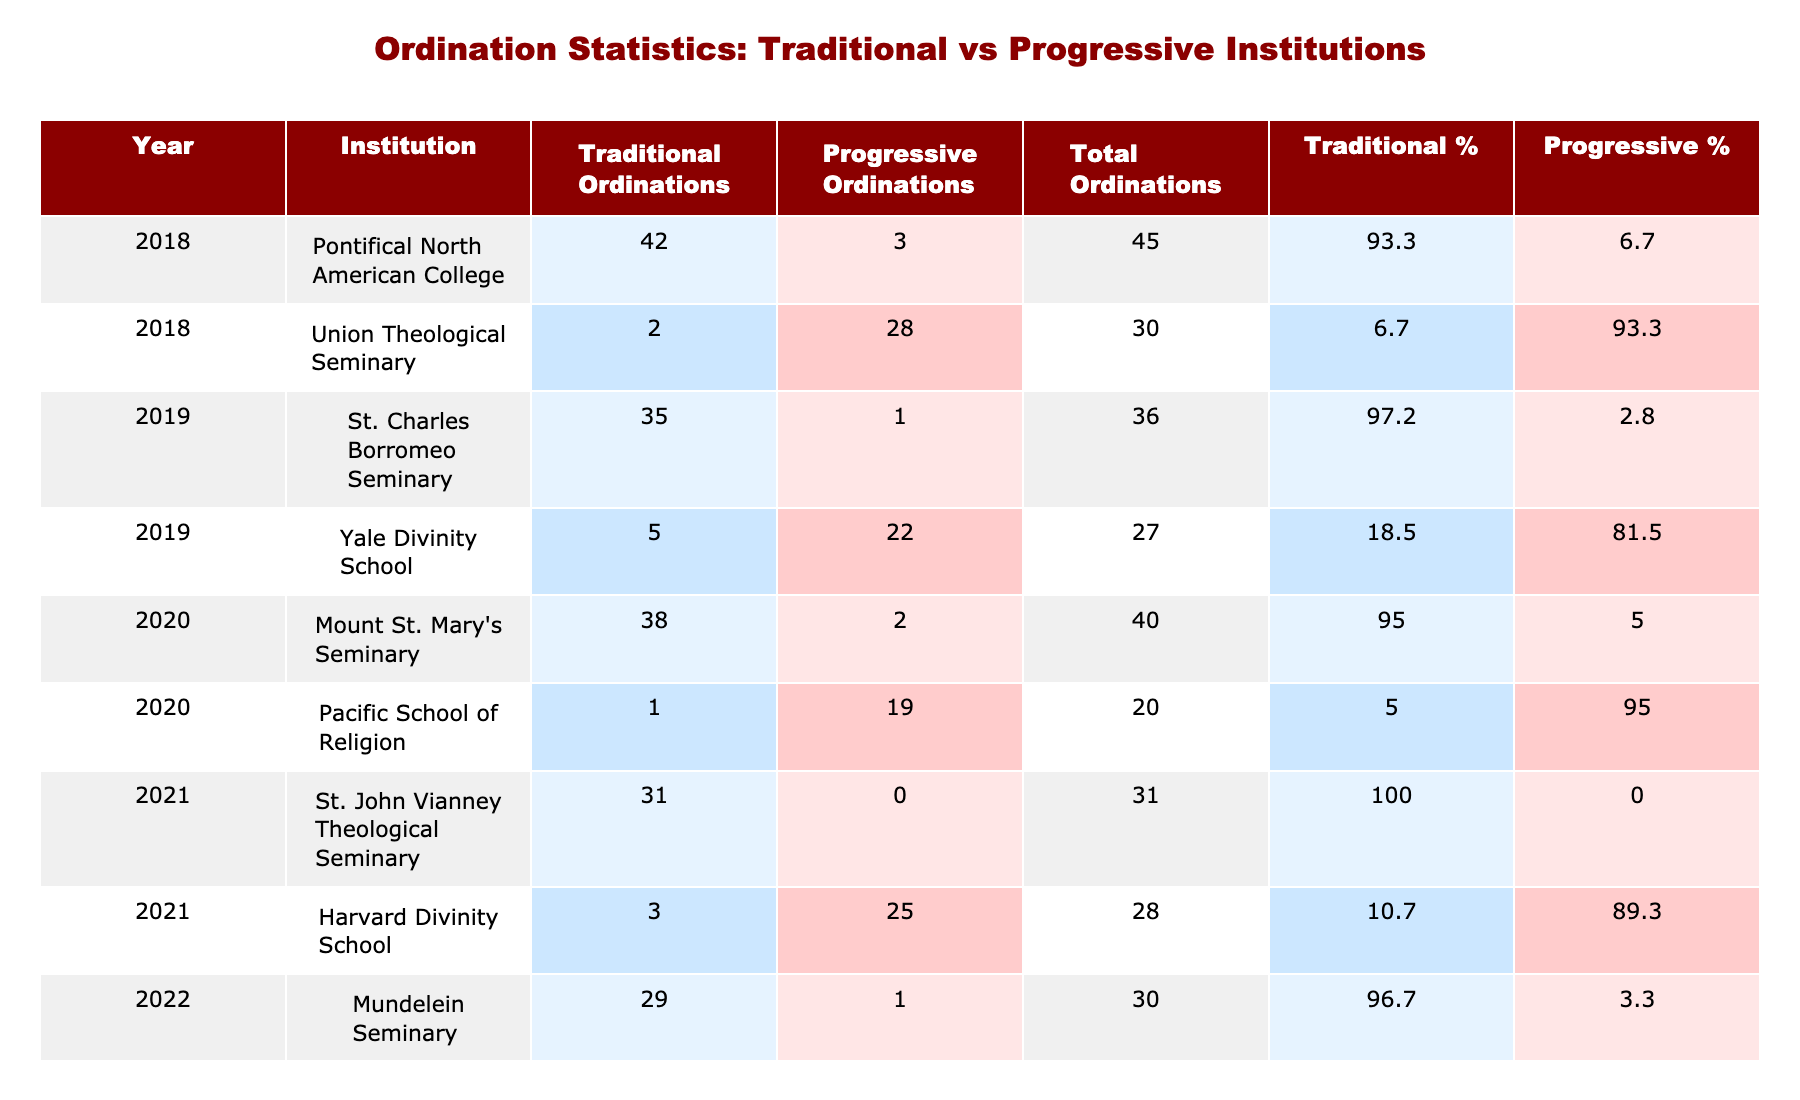What institution had the highest number of traditional ordinations in 2018? In 2018, the Pontifical North American College had 42 traditional ordinations, which is the highest compared to other institutions in that year.
Answer: Pontifical North American College What is the total number of progressive ordinations in 2020? In 2020, there were 2 progressive ordinations at Mount St. Mary's Seminary and 19 at Pacific School of Religion. The total is 2 + 19 = 21.
Answer: 21 Which institution had more traditional ordinations than progressive ordinations in 2019? In 2019, St. Charles Borromeo Seminary had 35 traditional ordinations and only 1 progressive ordination, indicating it had more traditional ordinations than progressive ones.
Answer: St. Charles Borromeo Seminary What percentage of total ordinations were traditional at Harvard Divinity School in 2021? Harvard Divinity School had 3 traditional ordinations and 25 progressive ordinations in 2021. The total ordinations were 3 + 25 = 28. The percentage of traditional ordinations is (3/28) * 100 ≈ 10.7%.
Answer: Approximately 10.7% How does the total number of traditional ordinations in 2022 compare to 2018? In 2022, there were 29 traditional ordinations in Mundelein Seminary and 0 in Chicago Theological Seminary, totaling 29. In 2018, there were 42 traditional ordinations. Comparing these, 29 is less than 42.
Answer: 29 is less than 42 Which year saw a decline in traditional ordinations at the Pontifical North American College compared to the previous year? In 2019, the Pontifical North American College had 42 ordinations, but it does not appear in the following year (2020) data, so we cannot assess a decline based on this dataset. Therefore, we conclude that 2020 does not have a value for this institution.
Answer: Not applicable Which institution had the lowest percentage of traditional ordinations in 2021? Harvard Divinity School had only 3 traditional ordinations out of 28 total ordinations in 2021, which is the lowest percentage among those listed for that year.
Answer: Harvard Divinity School What is the difference in total ordinations between St. Charles Borromeo Seminary and Yale Divinity School in 2019? In 2019, St. Charles Borromeo Seminary had 35 traditional ordinations and 1 progressive, totaling 36. Yale Divinity School had 5 traditional and 22 progressive ordinations, totaling 27. The difference is 36 - 27 = 9.
Answer: 9 What proportion of ordinations at the Pacific School of Religion were traditional in 2020? The Pacific School of Religion had 1 traditional and 19 progressive ordinations, totaling 20. The proportion of traditional ordinations is 1/20 = 0.05, or 5%.
Answer: 5% Which institution showed an increase in traditional ordinations from the previous year in 2022? Mundelein Seminary showed an increase by having 29 traditional ordinations in 2022 compared to previous numbers in other institutions listed for earlier years.
Answer: Mundelein Seminary 